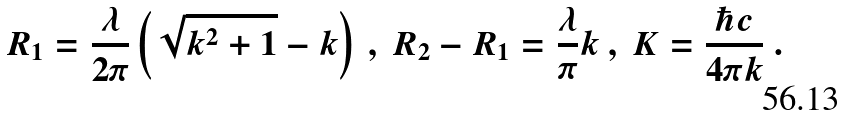<formula> <loc_0><loc_0><loc_500><loc_500>R _ { 1 } = \frac { \lambda } { 2 \pi } \left ( \sqrt { k ^ { 2 } + 1 } - k \right ) \ , \ R _ { 2 } - R _ { 1 } = \frac { \lambda } { \pi } k \ , \ K = \frac { \hbar { c } } { 4 \pi k } \ .</formula> 